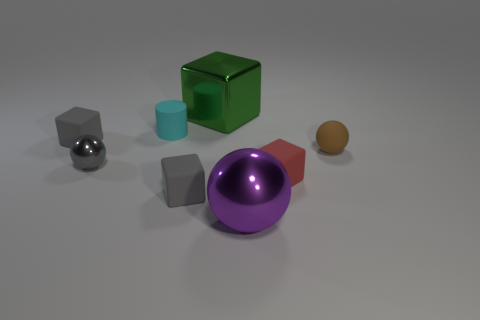Is there any other thing of the same color as the tiny metallic thing?
Offer a very short reply. Yes. Does the tiny gray object to the right of the tiny cyan cylinder have the same shape as the gray metal thing?
Provide a succinct answer. No. Is there a small gray rubber thing of the same shape as the brown object?
Offer a terse response. No. How many things are purple metal spheres that are on the right side of the big green metallic block or purple metal things?
Keep it short and to the point. 1. Are there more cyan matte spheres than small rubber balls?
Ensure brevity in your answer.  No. Is there a purple metal thing that has the same size as the cyan cylinder?
Make the answer very short. No. How many objects are either large shiny things that are left of the purple metallic ball or small things on the left side of the gray sphere?
Offer a very short reply. 2. The small sphere left of the big object that is in front of the brown matte sphere is what color?
Your answer should be compact. Gray. There is a small cylinder that is made of the same material as the brown sphere; what is its color?
Provide a short and direct response. Cyan. What number of small shiny things have the same color as the shiny cube?
Your answer should be very brief. 0. 